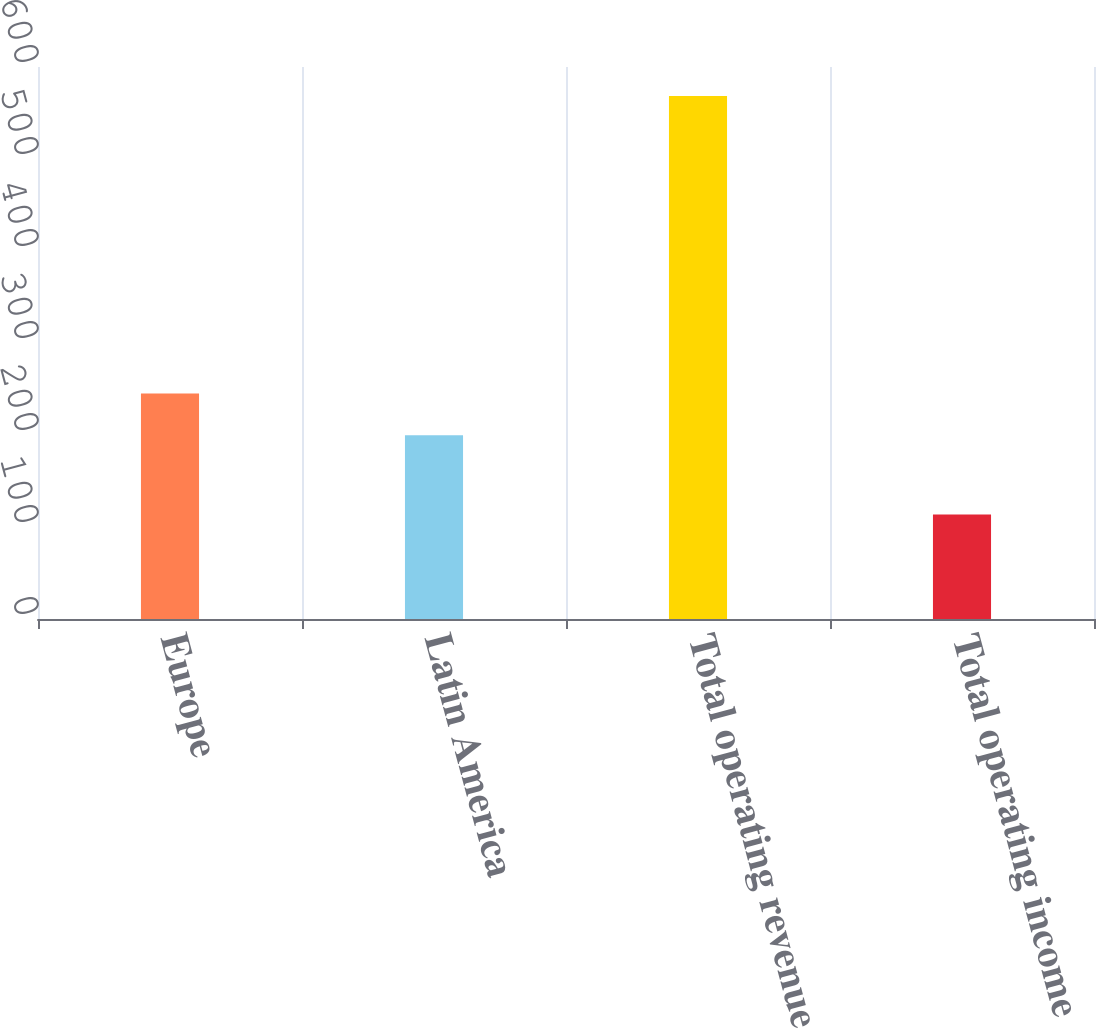<chart> <loc_0><loc_0><loc_500><loc_500><bar_chart><fcel>Europe<fcel>Latin America<fcel>Total operating revenue<fcel>Total operating income<nl><fcel>245.1<fcel>199.6<fcel>568.5<fcel>113.5<nl></chart> 